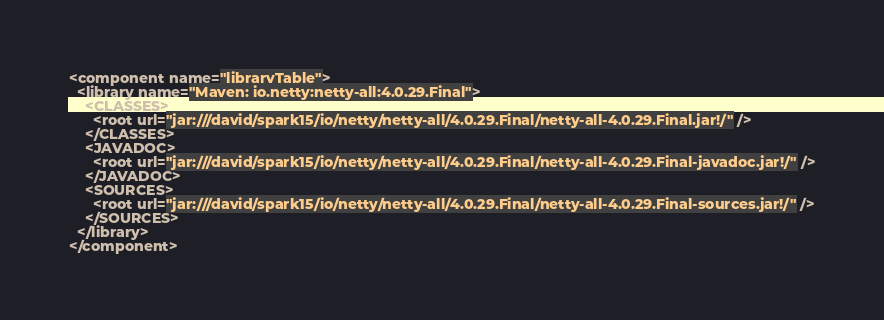<code> <loc_0><loc_0><loc_500><loc_500><_XML_><component name="libraryTable">
  <library name="Maven: io.netty:netty-all:4.0.29.Final">
    <CLASSES>
      <root url="jar:///david/spark15/io/netty/netty-all/4.0.29.Final/netty-all-4.0.29.Final.jar!/" />
    </CLASSES>
    <JAVADOC>
      <root url="jar:///david/spark15/io/netty/netty-all/4.0.29.Final/netty-all-4.0.29.Final-javadoc.jar!/" />
    </JAVADOC>
    <SOURCES>
      <root url="jar:///david/spark15/io/netty/netty-all/4.0.29.Final/netty-all-4.0.29.Final-sources.jar!/" />
    </SOURCES>
  </library>
</component></code> 